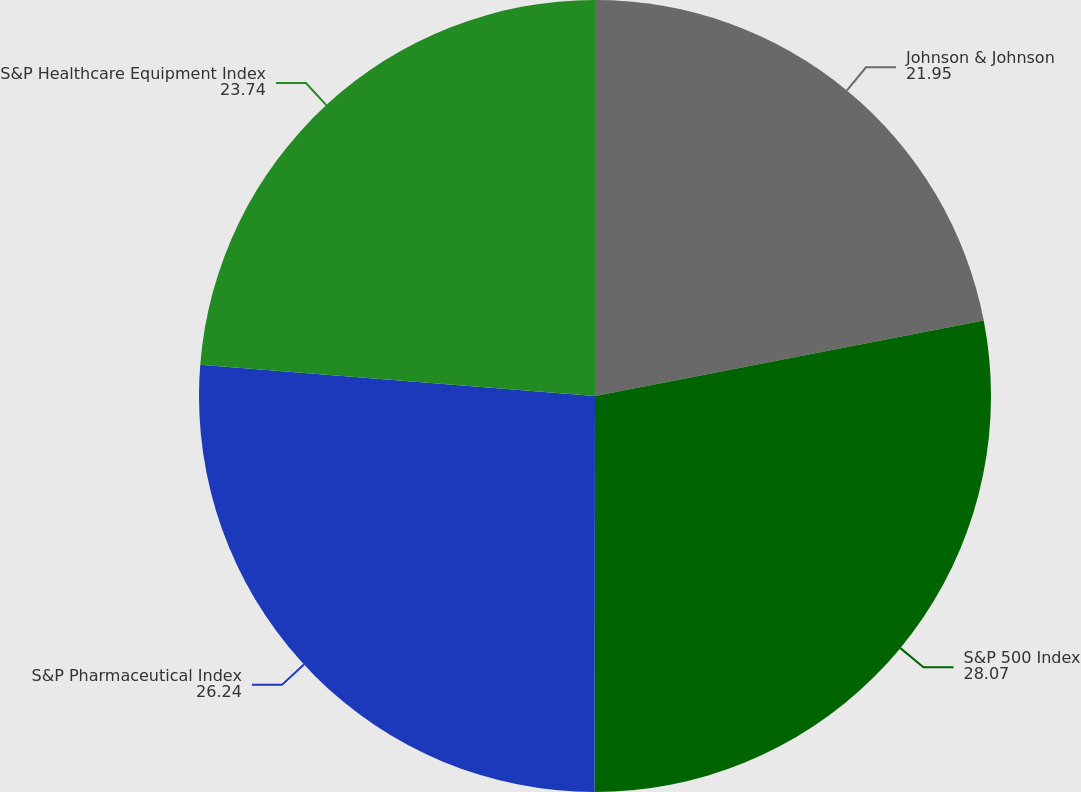<chart> <loc_0><loc_0><loc_500><loc_500><pie_chart><fcel>Johnson & Johnson<fcel>S&P 500 Index<fcel>S&P Pharmaceutical Index<fcel>S&P Healthcare Equipment Index<nl><fcel>21.95%<fcel>28.07%<fcel>26.24%<fcel>23.74%<nl></chart> 